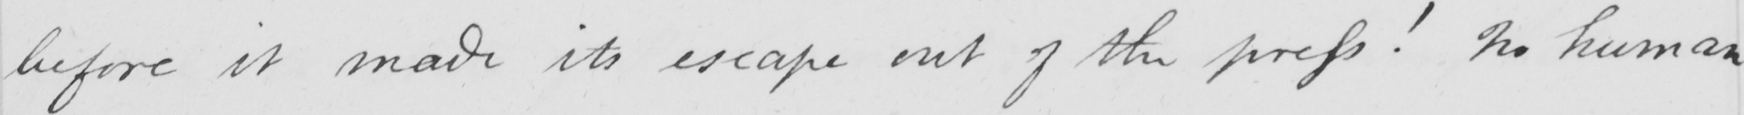Please transcribe the handwritten text in this image. before it made its escape out of the press !  No human 